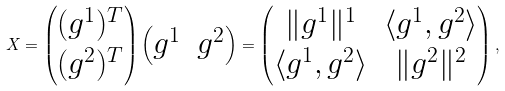Convert formula to latex. <formula><loc_0><loc_0><loc_500><loc_500>X = \begin{pmatrix} ( g ^ { 1 } ) ^ { T } \\ ( g ^ { 2 } ) ^ { T } \end{pmatrix} \begin{pmatrix} g ^ { 1 } & g ^ { 2 } \end{pmatrix} = \begin{pmatrix} \| g ^ { 1 } \| ^ { 1 } & \langle g ^ { 1 } , g ^ { 2 } \rangle \\ \langle g ^ { 1 } , g ^ { 2 } \rangle & \| g ^ { 2 } \| ^ { 2 } \end{pmatrix} ,</formula> 